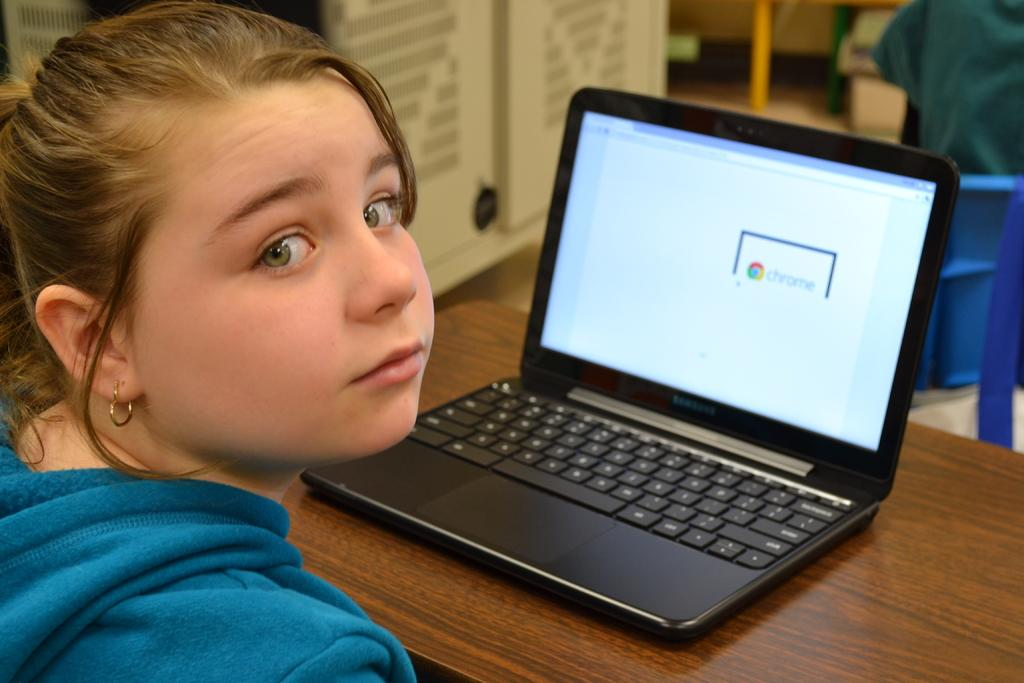Who or what is the main subject in the image? There is a person in the image. What is in front of the person? There is a table in front of the person. What is on top of the table? There is a laptop on top of the table. What can be seen behind the table? There are a few objects behind the table. How many girls are visible in the image? There is no mention of girls in the provided facts, and therefore we cannot determine the number of girls in the image. 